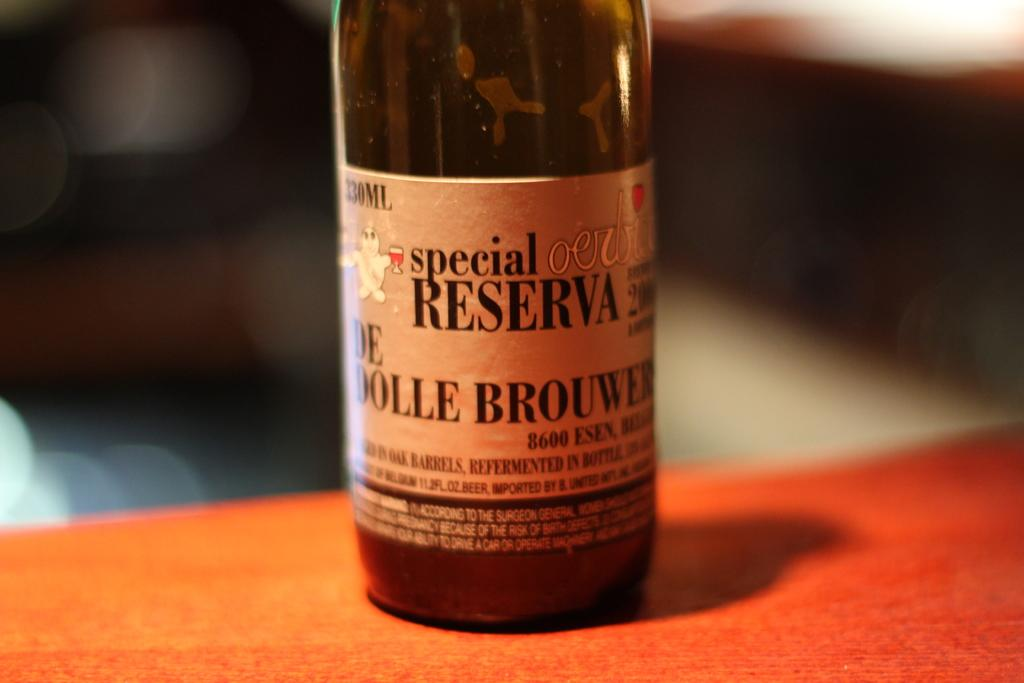<image>
Share a concise interpretation of the image provided. a bottle of special reserva with a white label 